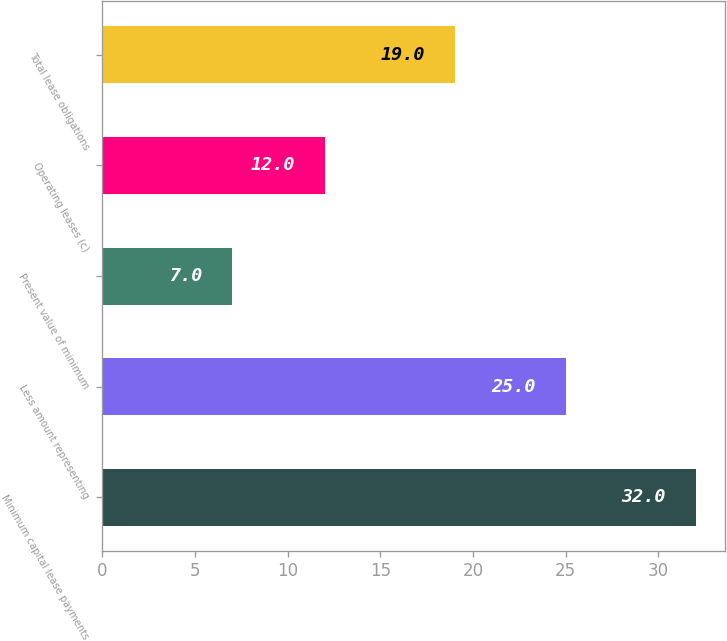Convert chart to OTSL. <chart><loc_0><loc_0><loc_500><loc_500><bar_chart><fcel>Minimum capital lease payments<fcel>Less amount representing<fcel>Present value of minimum<fcel>Operating leases (c)<fcel>Total lease obligations<nl><fcel>32<fcel>25<fcel>7<fcel>12<fcel>19<nl></chart> 